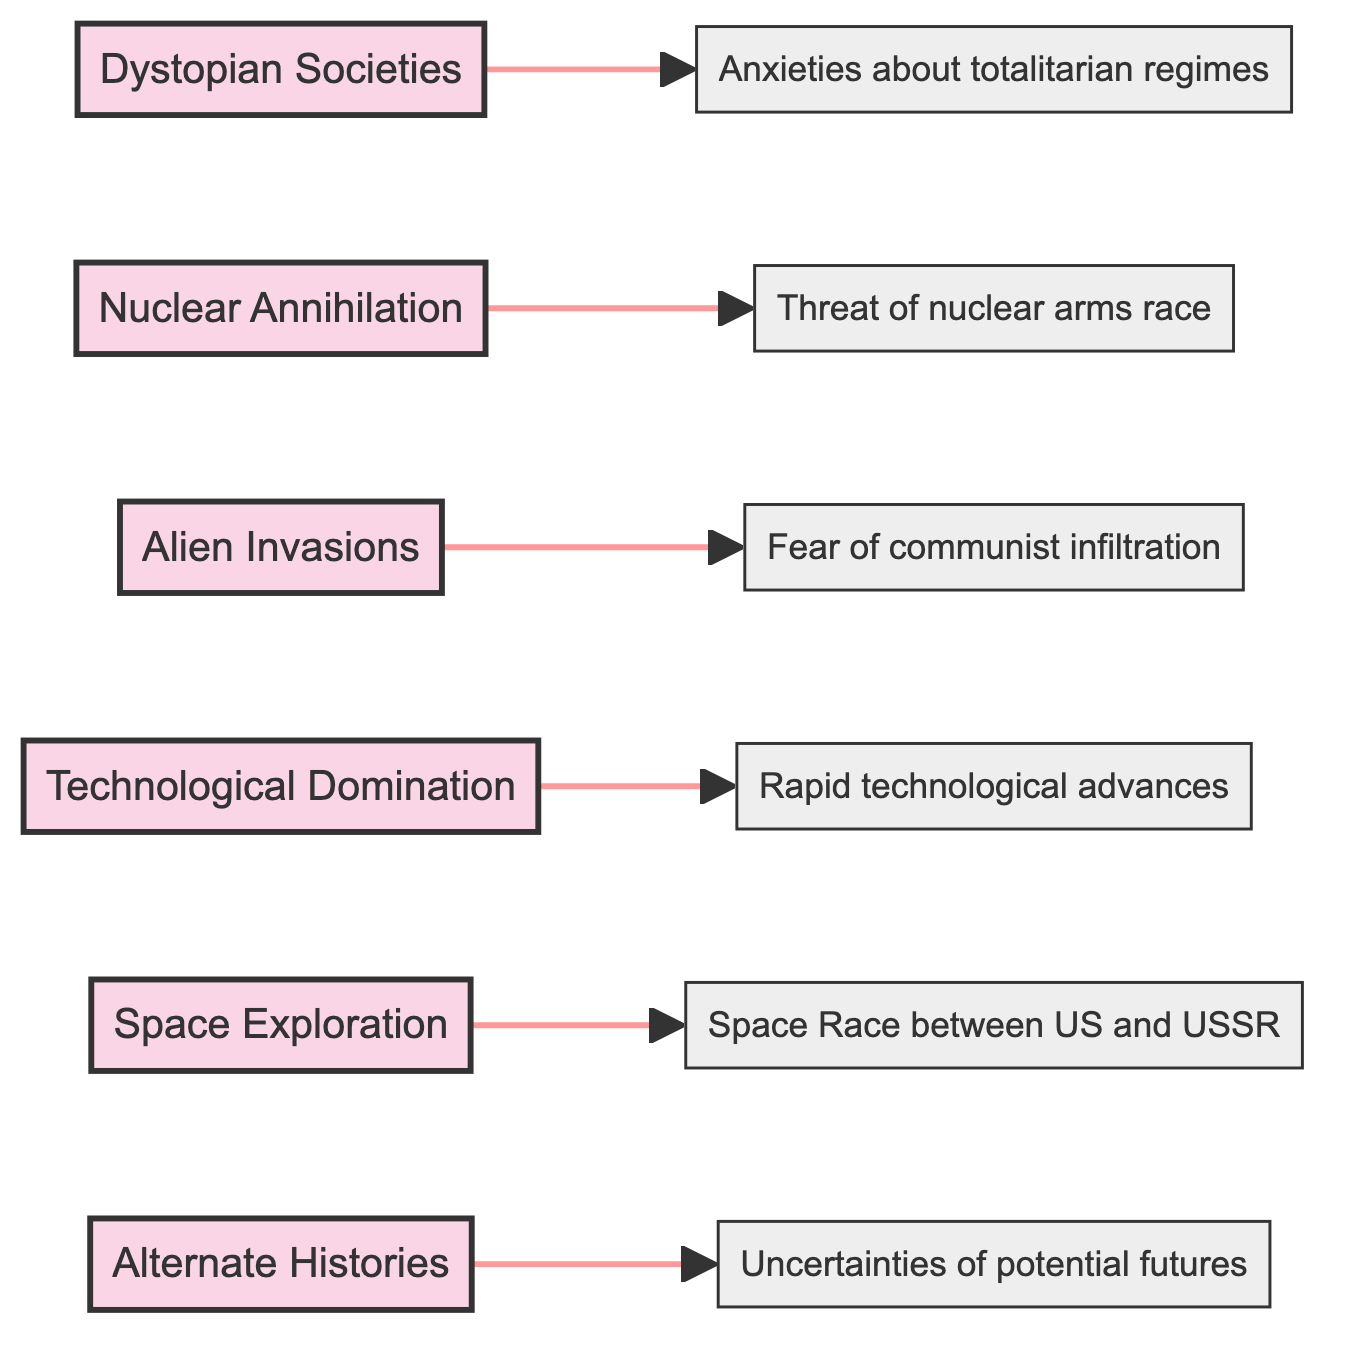What is the theme that relates to oppressive governments? The node titled "Dystopian Societies" directly addresses the concept of oppressive governments within its description.
Answer: Dystopian Societies Which historical context corresponds with "Alien Invasions"? The description node connected to "Alien Invasions" states "Fear of communist infiltration," indicating this historical context.
Answer: Fear of communist infiltration How many themes are presented in this diagram? The diagram contains a total of six themes, as noted by the six nodes labeled with various themes in the flowchart.
Answer: 6 What theme is concerned with the aftermath of nuclear war? The theme named "Nuclear Annihilation" specifically focuses on stories that explore the consequences of nuclear war.
Answer: Nuclear Annihilation Which theme discusses advanced technology and its impacts? The theme titled "Technological Domination" discusses advanced technology, highlighting aspects such as dehumanization and control.
Answer: Technological Domination What historical context is linked to "Space Exploration"? The node for "Space Exploration" connects to the historical context stating "Space Race between US and USSR."
Answer: Space Race between US and USSR What is the theme that involves imagining alternate outcomes for historical events? The theme "Alternate Histories" explicitly covers narratives that consider different outcomes of historical events.
Answer: Alternate Histories Which theme reflects anxieties about totalitarian regimes? The historical context linked to "Dystopian Societies" addresses the anxieties surrounding totalitarian regimes.
Answer: Anxieties about totalitarian regimes Is "Nuclear Annihilation" connected to a broader theme of fear? Yes, it connects to the broader theme of nuclear threat, represented by its relationship to the historical context concerning the nuclear arms race.
Answer: Yes 